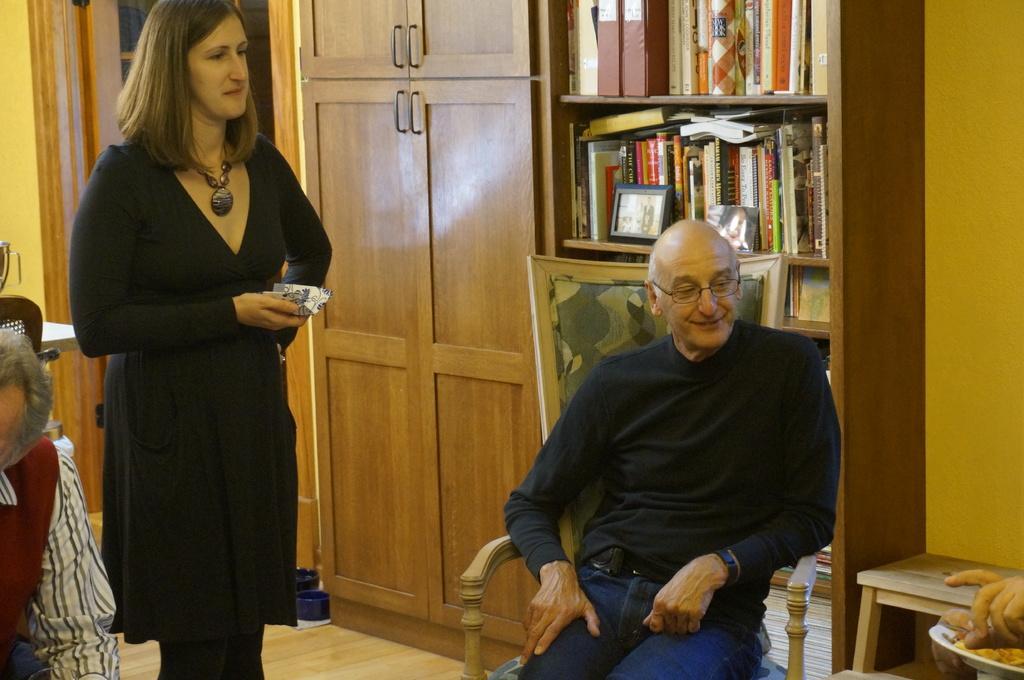In one or two sentences, can you explain what this image depicts? In this picture we can see two persons sitting and a woman standing, in the background there are some cupboards, on the right side there is a rack and a wall, we can see some books and files on the rack, at the right bottom there is a table, a woman in the middle is holding something. 